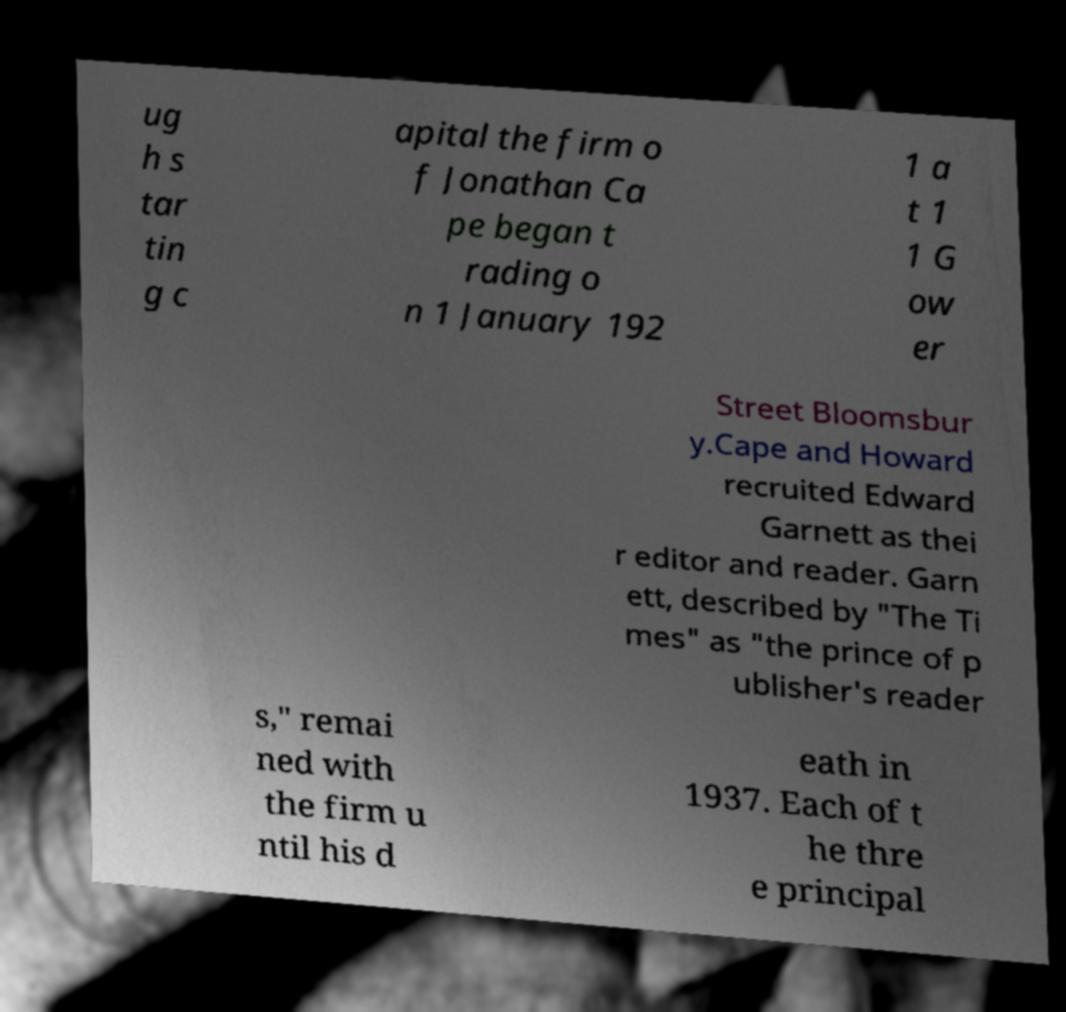Could you assist in decoding the text presented in this image and type it out clearly? ug h s tar tin g c apital the firm o f Jonathan Ca pe began t rading o n 1 January 192 1 a t 1 1 G ow er Street Bloomsbur y.Cape and Howard recruited Edward Garnett as thei r editor and reader. Garn ett, described by "The Ti mes" as "the prince of p ublisher's reader s," remai ned with the firm u ntil his d eath in 1937. Each of t he thre e principal 